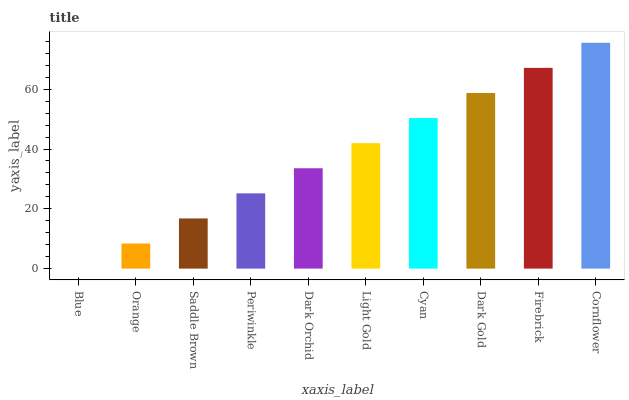Is Blue the minimum?
Answer yes or no. Yes. Is Cornflower the maximum?
Answer yes or no. Yes. Is Orange the minimum?
Answer yes or no. No. Is Orange the maximum?
Answer yes or no. No. Is Orange greater than Blue?
Answer yes or no. Yes. Is Blue less than Orange?
Answer yes or no. Yes. Is Blue greater than Orange?
Answer yes or no. No. Is Orange less than Blue?
Answer yes or no. No. Is Light Gold the high median?
Answer yes or no. Yes. Is Dark Orchid the low median?
Answer yes or no. Yes. Is Cornflower the high median?
Answer yes or no. No. Is Blue the low median?
Answer yes or no. No. 